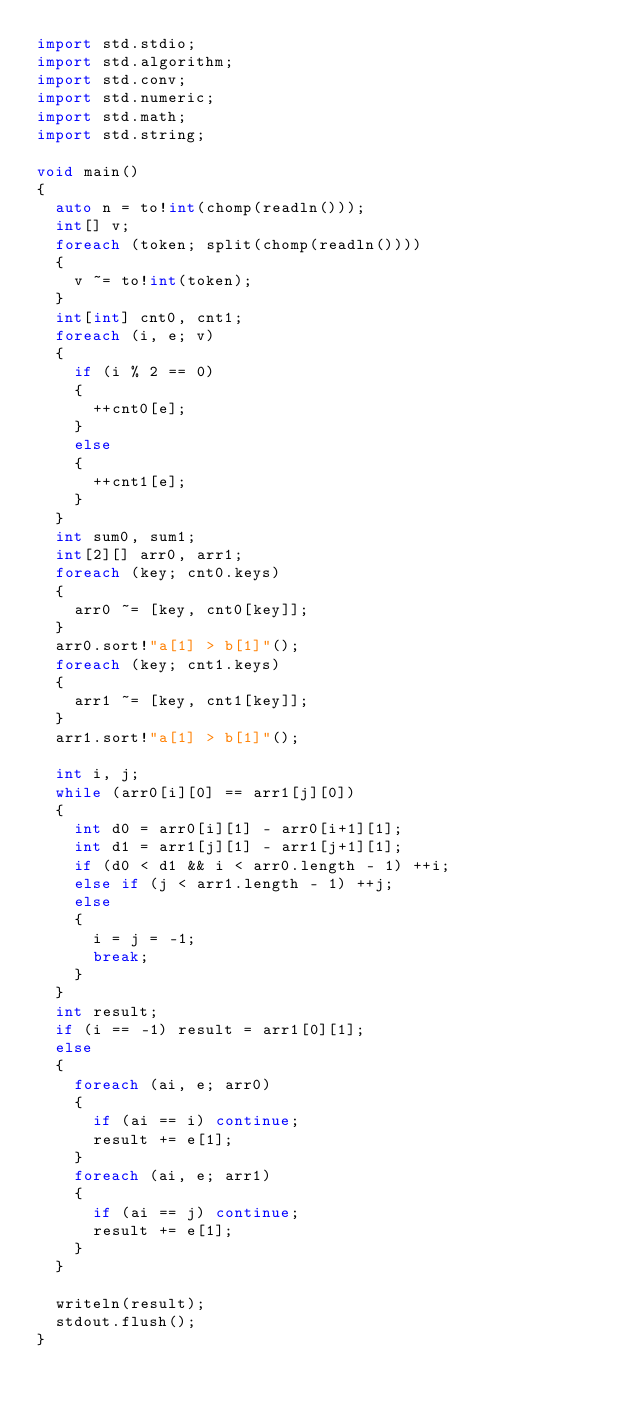Convert code to text. <code><loc_0><loc_0><loc_500><loc_500><_D_>import std.stdio;
import std.algorithm;
import std.conv;
import std.numeric;
import std.math;
import std.string;

void main()
{
	auto n = to!int(chomp(readln()));
	int[] v;
	foreach (token; split(chomp(readln())))
	{
		v ~= to!int(token);
	}
	int[int] cnt0, cnt1;
	foreach (i, e; v)
	{
		if (i % 2 == 0)
		{
			++cnt0[e];
		}
		else
		{
			++cnt1[e];
		}
	}
	int sum0, sum1;
	int[2][] arr0, arr1;
	foreach (key; cnt0.keys)
	{
		arr0 ~= [key, cnt0[key]];
	}
	arr0.sort!"a[1] > b[1]"();
	foreach (key; cnt1.keys)
	{
		arr1 ~= [key, cnt1[key]];
	}
	arr1.sort!"a[1] > b[1]"();

	int i, j;
	while (arr0[i][0] == arr1[j][0])
	{
		int d0 = arr0[i][1] - arr0[i+1][1];
		int d1 = arr1[j][1] - arr1[j+1][1];
		if (d0 < d1 && i < arr0.length - 1) ++i;
		else if (j < arr1.length - 1) ++j;
		else
		{
			i = j = -1;
			break;
		}
	}
	int result;
	if (i == -1) result = arr1[0][1];
	else
	{
		foreach (ai, e; arr0)
		{
			if (ai == i) continue;
			result += e[1];
		}
		foreach (ai, e; arr1)
		{
			if (ai == j) continue;
			result += e[1];
		}
	}

	writeln(result);
	stdout.flush();
}</code> 